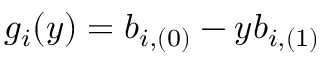<formula> <loc_0><loc_0><loc_500><loc_500>g _ { i } ( y ) = b _ { i , ( 0 ) } - y b _ { i , ( 1 ) }</formula> 